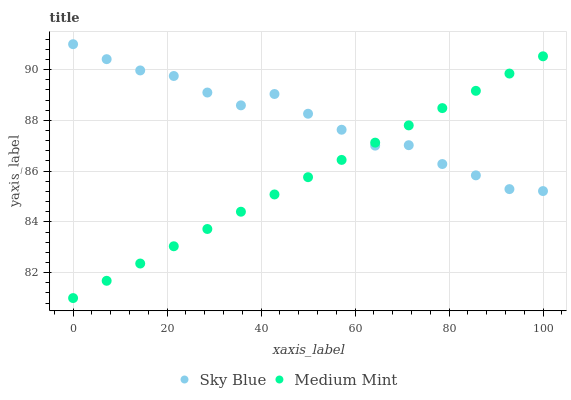Does Medium Mint have the minimum area under the curve?
Answer yes or no. Yes. Does Sky Blue have the maximum area under the curve?
Answer yes or no. Yes. Does Sky Blue have the minimum area under the curve?
Answer yes or no. No. Is Medium Mint the smoothest?
Answer yes or no. Yes. Is Sky Blue the roughest?
Answer yes or no. Yes. Is Sky Blue the smoothest?
Answer yes or no. No. Does Medium Mint have the lowest value?
Answer yes or no. Yes. Does Sky Blue have the lowest value?
Answer yes or no. No. Does Sky Blue have the highest value?
Answer yes or no. Yes. Does Sky Blue intersect Medium Mint?
Answer yes or no. Yes. Is Sky Blue less than Medium Mint?
Answer yes or no. No. Is Sky Blue greater than Medium Mint?
Answer yes or no. No. 